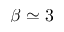<formula> <loc_0><loc_0><loc_500><loc_500>\beta \simeq 3</formula> 